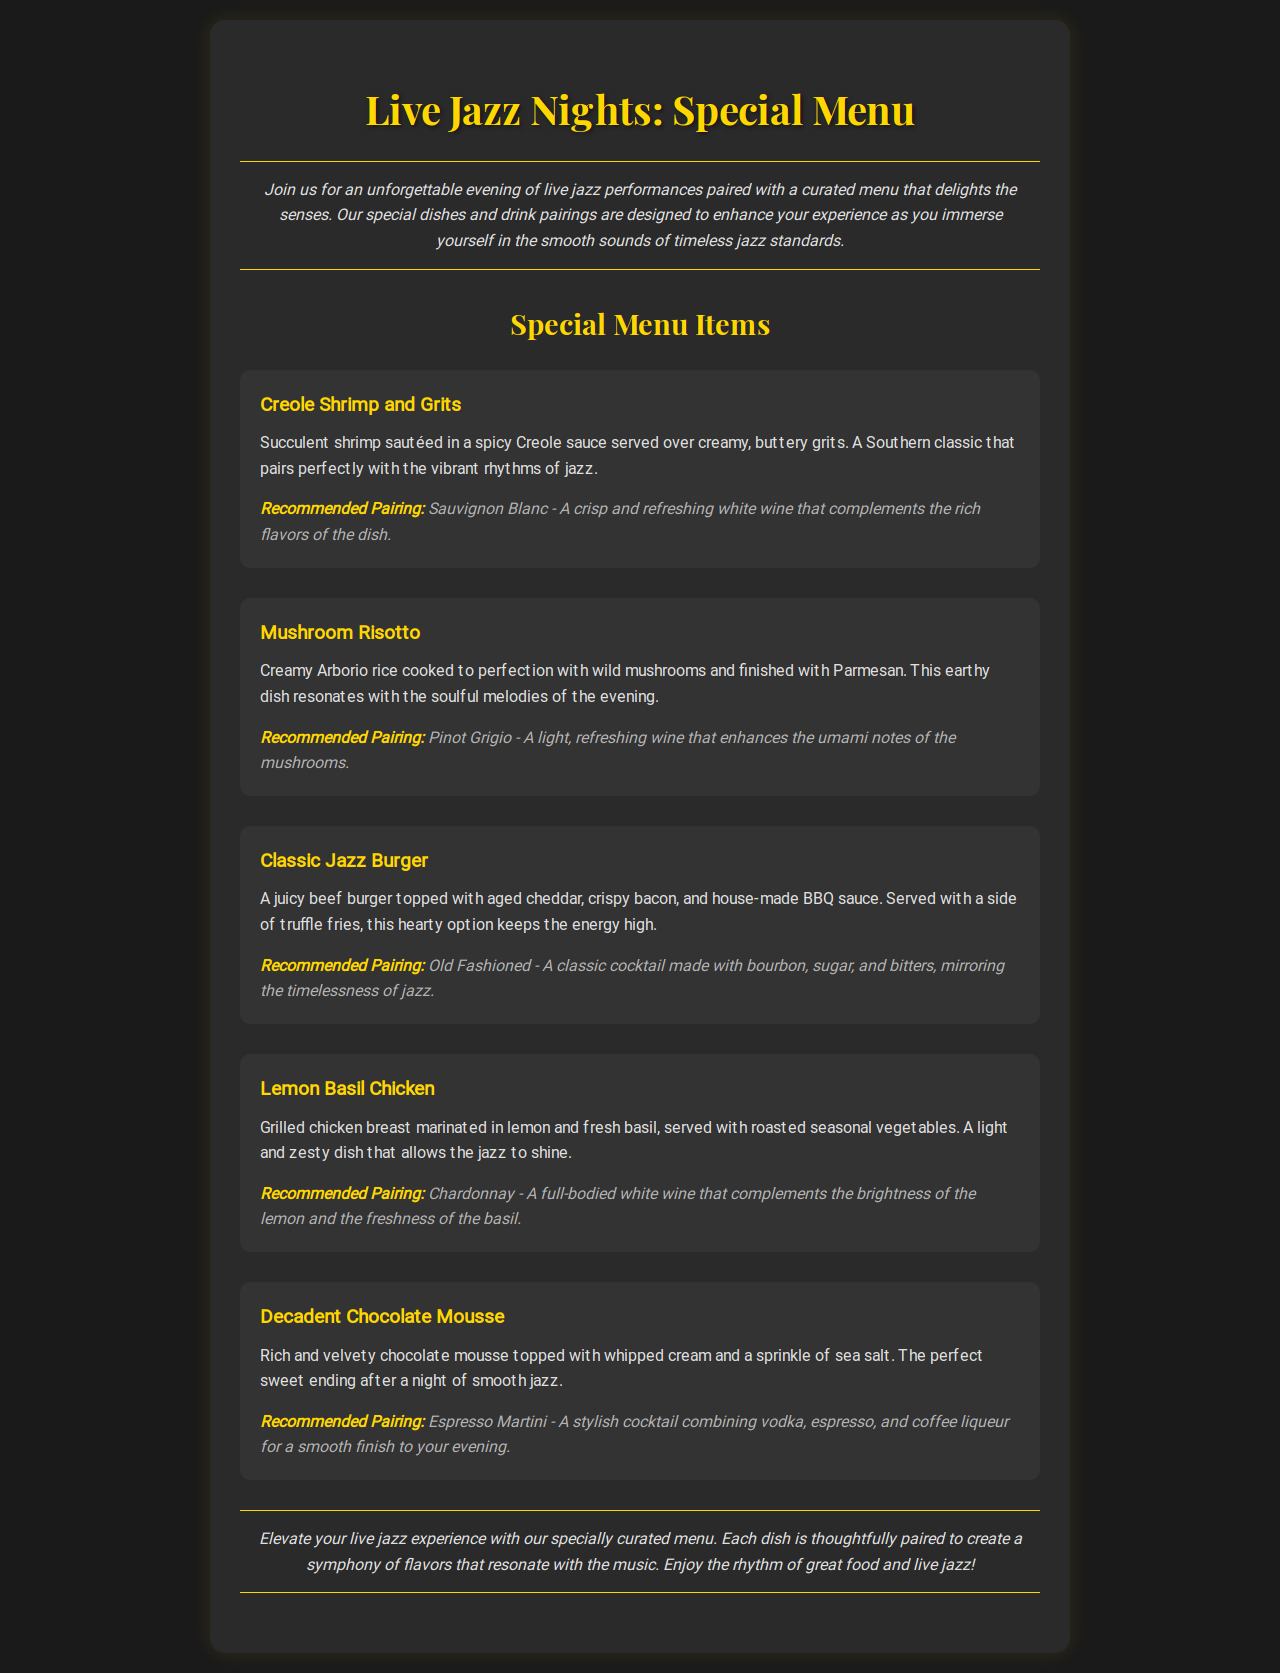What is the title of the event? The title of the event is prominently displayed at the top of the document.
Answer: Live Jazz Nights: Special Menu What dish is paired with Sauvignon Blanc? The dish recommended to pair with Sauvignon Blanc is mentioned in the pairing section of the menu items.
Answer: Creole Shrimp and Grits How many special menu items are listed? The number of special menu items can be counted from the list provided under the Special Menu Items section.
Answer: Five Which dish has a zesty flavor profile? The description of this dish indicates its zesty nature related to its ingredients.
Answer: Lemon Basil Chicken What is the recommended cocktail for the Classic Jazz Burger? The pairing information specifically states the recommended cocktail for this dish.
Answer: Old Fashioned Which dessert completes the evening? The dessert that’s highlighted as a sweet ending to the meal is detailed in the last menu item.
Answer: Decadent Chocolate Mousse 